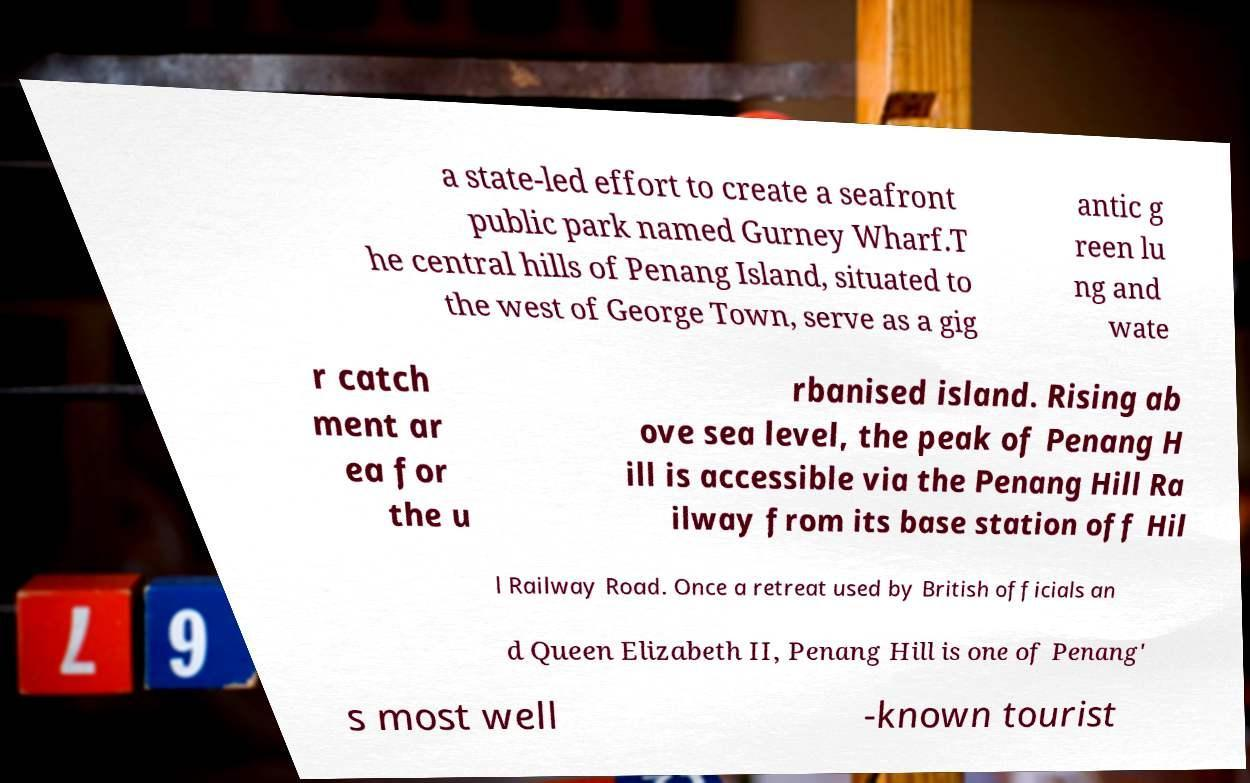There's text embedded in this image that I need extracted. Can you transcribe it verbatim? a state-led effort to create a seafront public park named Gurney Wharf.T he central hills of Penang Island, situated to the west of George Town, serve as a gig antic g reen lu ng and wate r catch ment ar ea for the u rbanised island. Rising ab ove sea level, the peak of Penang H ill is accessible via the Penang Hill Ra ilway from its base station off Hil l Railway Road. Once a retreat used by British officials an d Queen Elizabeth II, Penang Hill is one of Penang' s most well -known tourist 